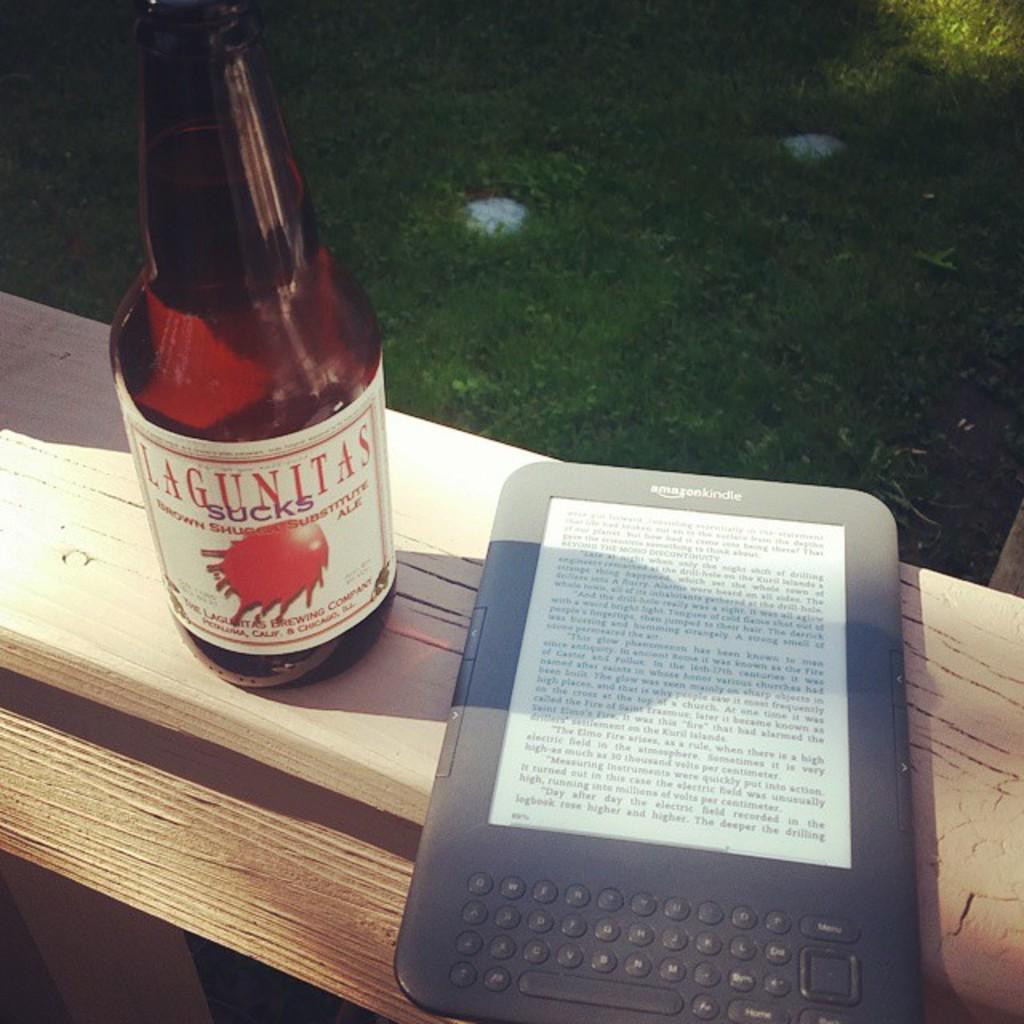What kind of beer is this?
Your answer should be compact. Lagunitas. What´s the brand of this beer?
Your answer should be very brief. Lagunitas. 